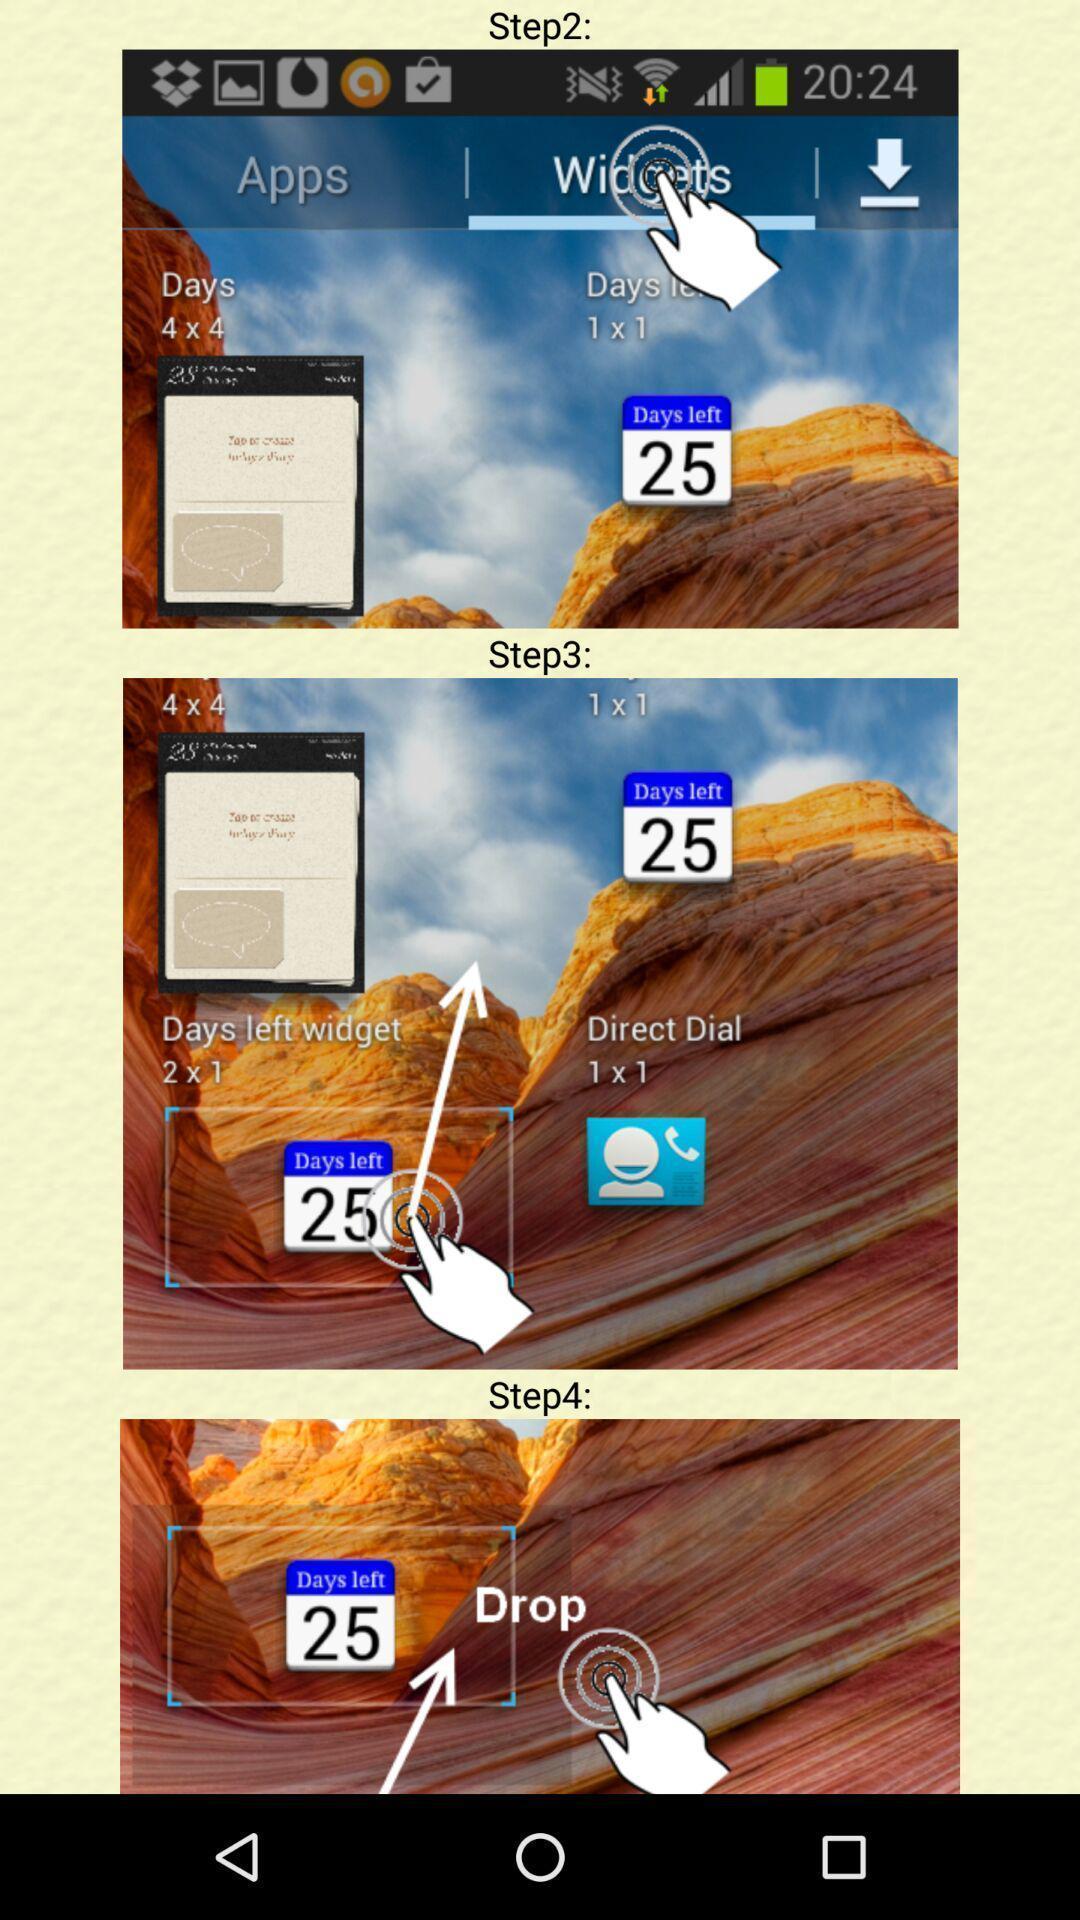Please provide a description for this image. Screen shows multiple steps. 